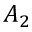Convert formula to latex. <formula><loc_0><loc_0><loc_500><loc_500>A _ { 2 }</formula> 